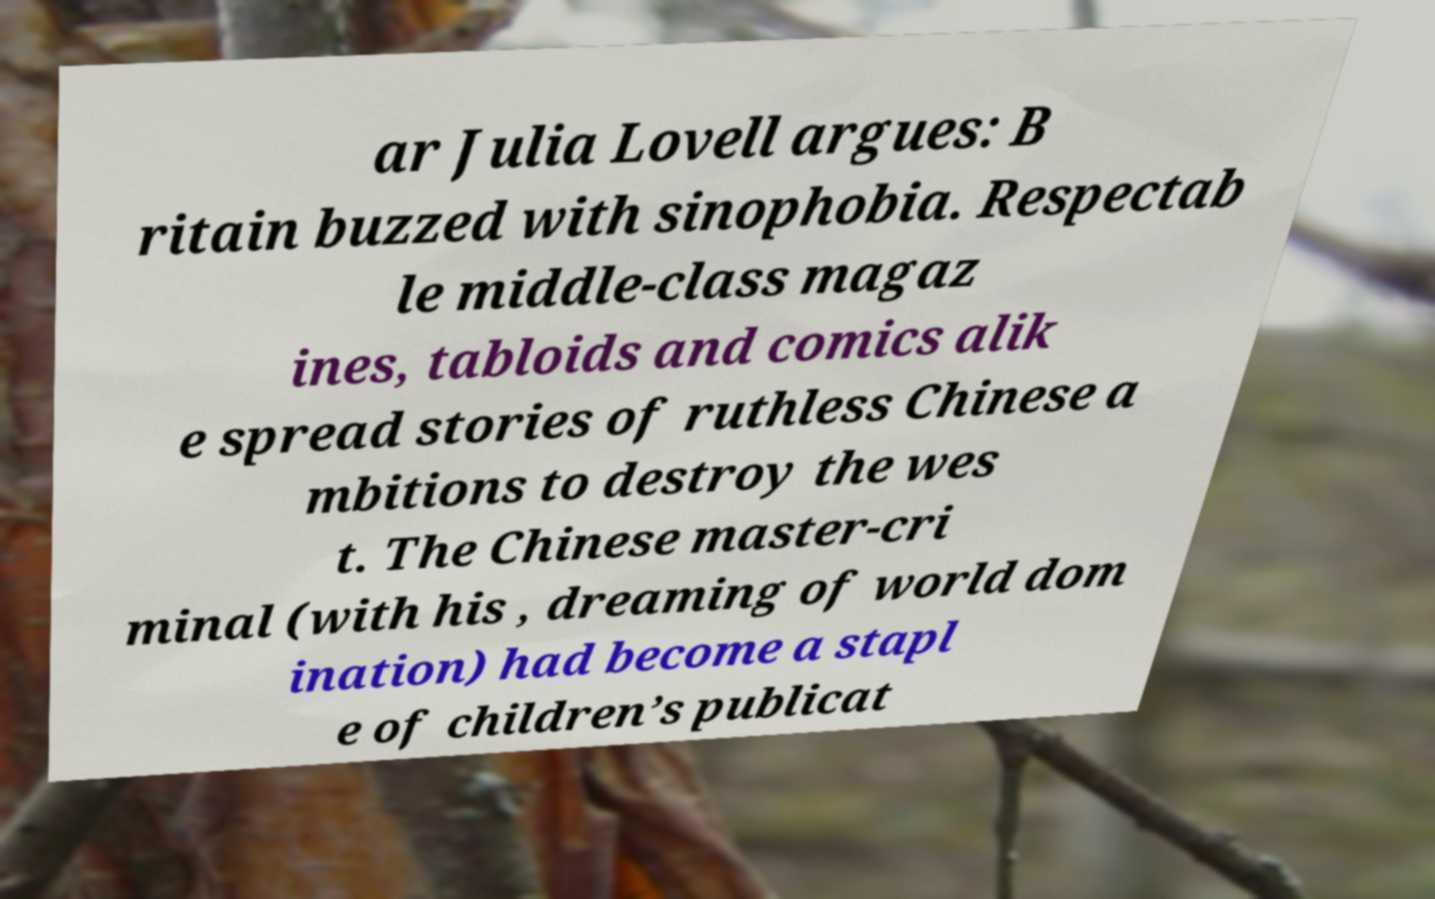I need the written content from this picture converted into text. Can you do that? ar Julia Lovell argues: B ritain buzzed with sinophobia. Respectab le middle-class magaz ines, tabloids and comics alik e spread stories of ruthless Chinese a mbitions to destroy the wes t. The Chinese master-cri minal (with his , dreaming of world dom ination) had become a stapl e of children’s publicat 